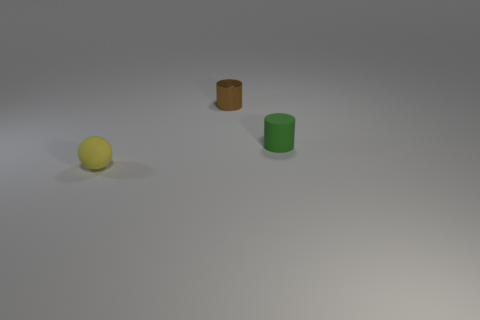Subtract all blue balls. Subtract all blue blocks. How many balls are left? 1 Add 1 big purple blocks. How many objects exist? 4 Subtract all cylinders. How many objects are left? 1 Add 2 tiny rubber spheres. How many tiny rubber spheres exist? 3 Subtract 1 green cylinders. How many objects are left? 2 Subtract all tiny yellow rubber things. Subtract all rubber cylinders. How many objects are left? 1 Add 1 small brown shiny objects. How many small brown shiny objects are left? 2 